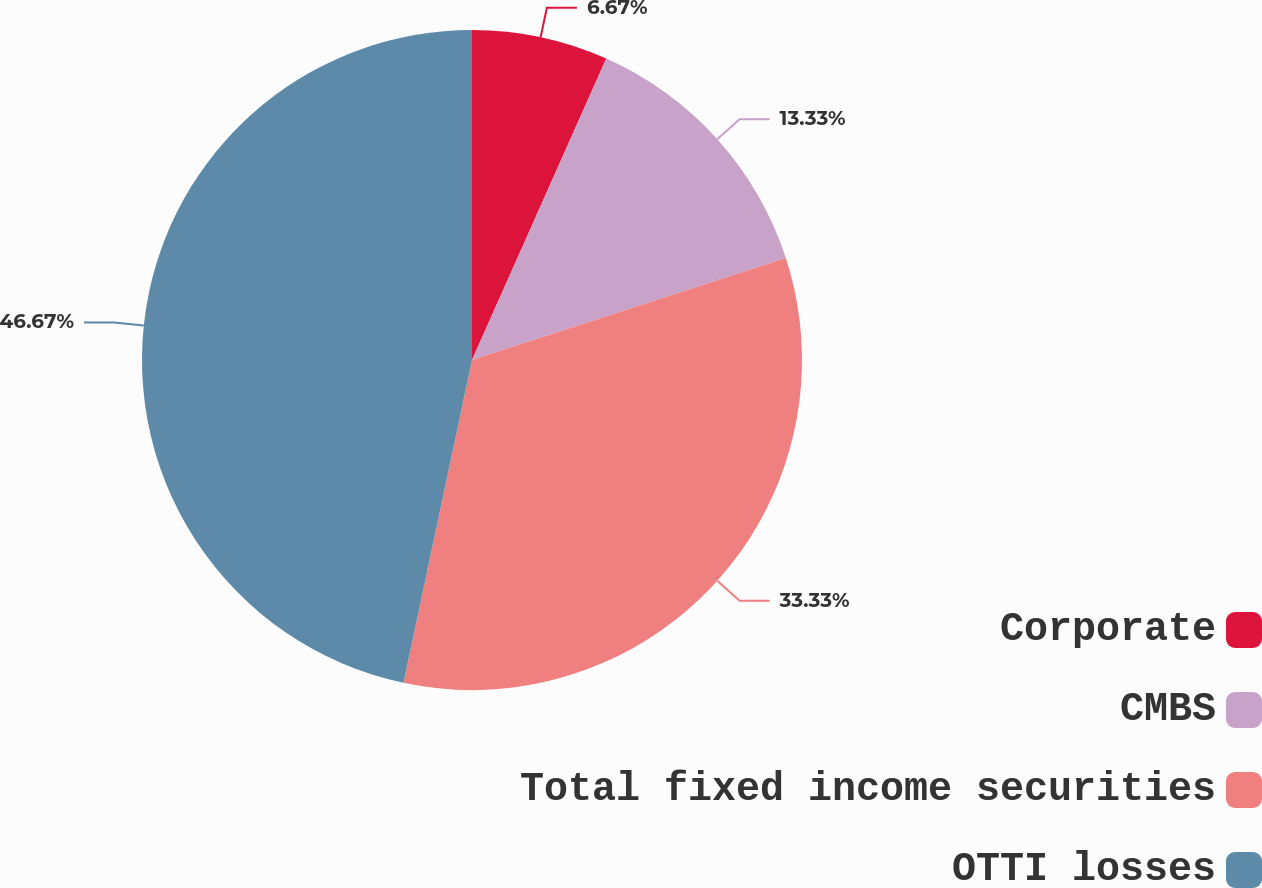Convert chart. <chart><loc_0><loc_0><loc_500><loc_500><pie_chart><fcel>Corporate<fcel>CMBS<fcel>Total fixed income securities<fcel>OTTI losses<nl><fcel>6.67%<fcel>13.33%<fcel>33.33%<fcel>46.67%<nl></chart> 